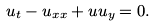Convert formula to latex. <formula><loc_0><loc_0><loc_500><loc_500>u _ { t } - u _ { x x } + u u _ { y } = 0 .</formula> 